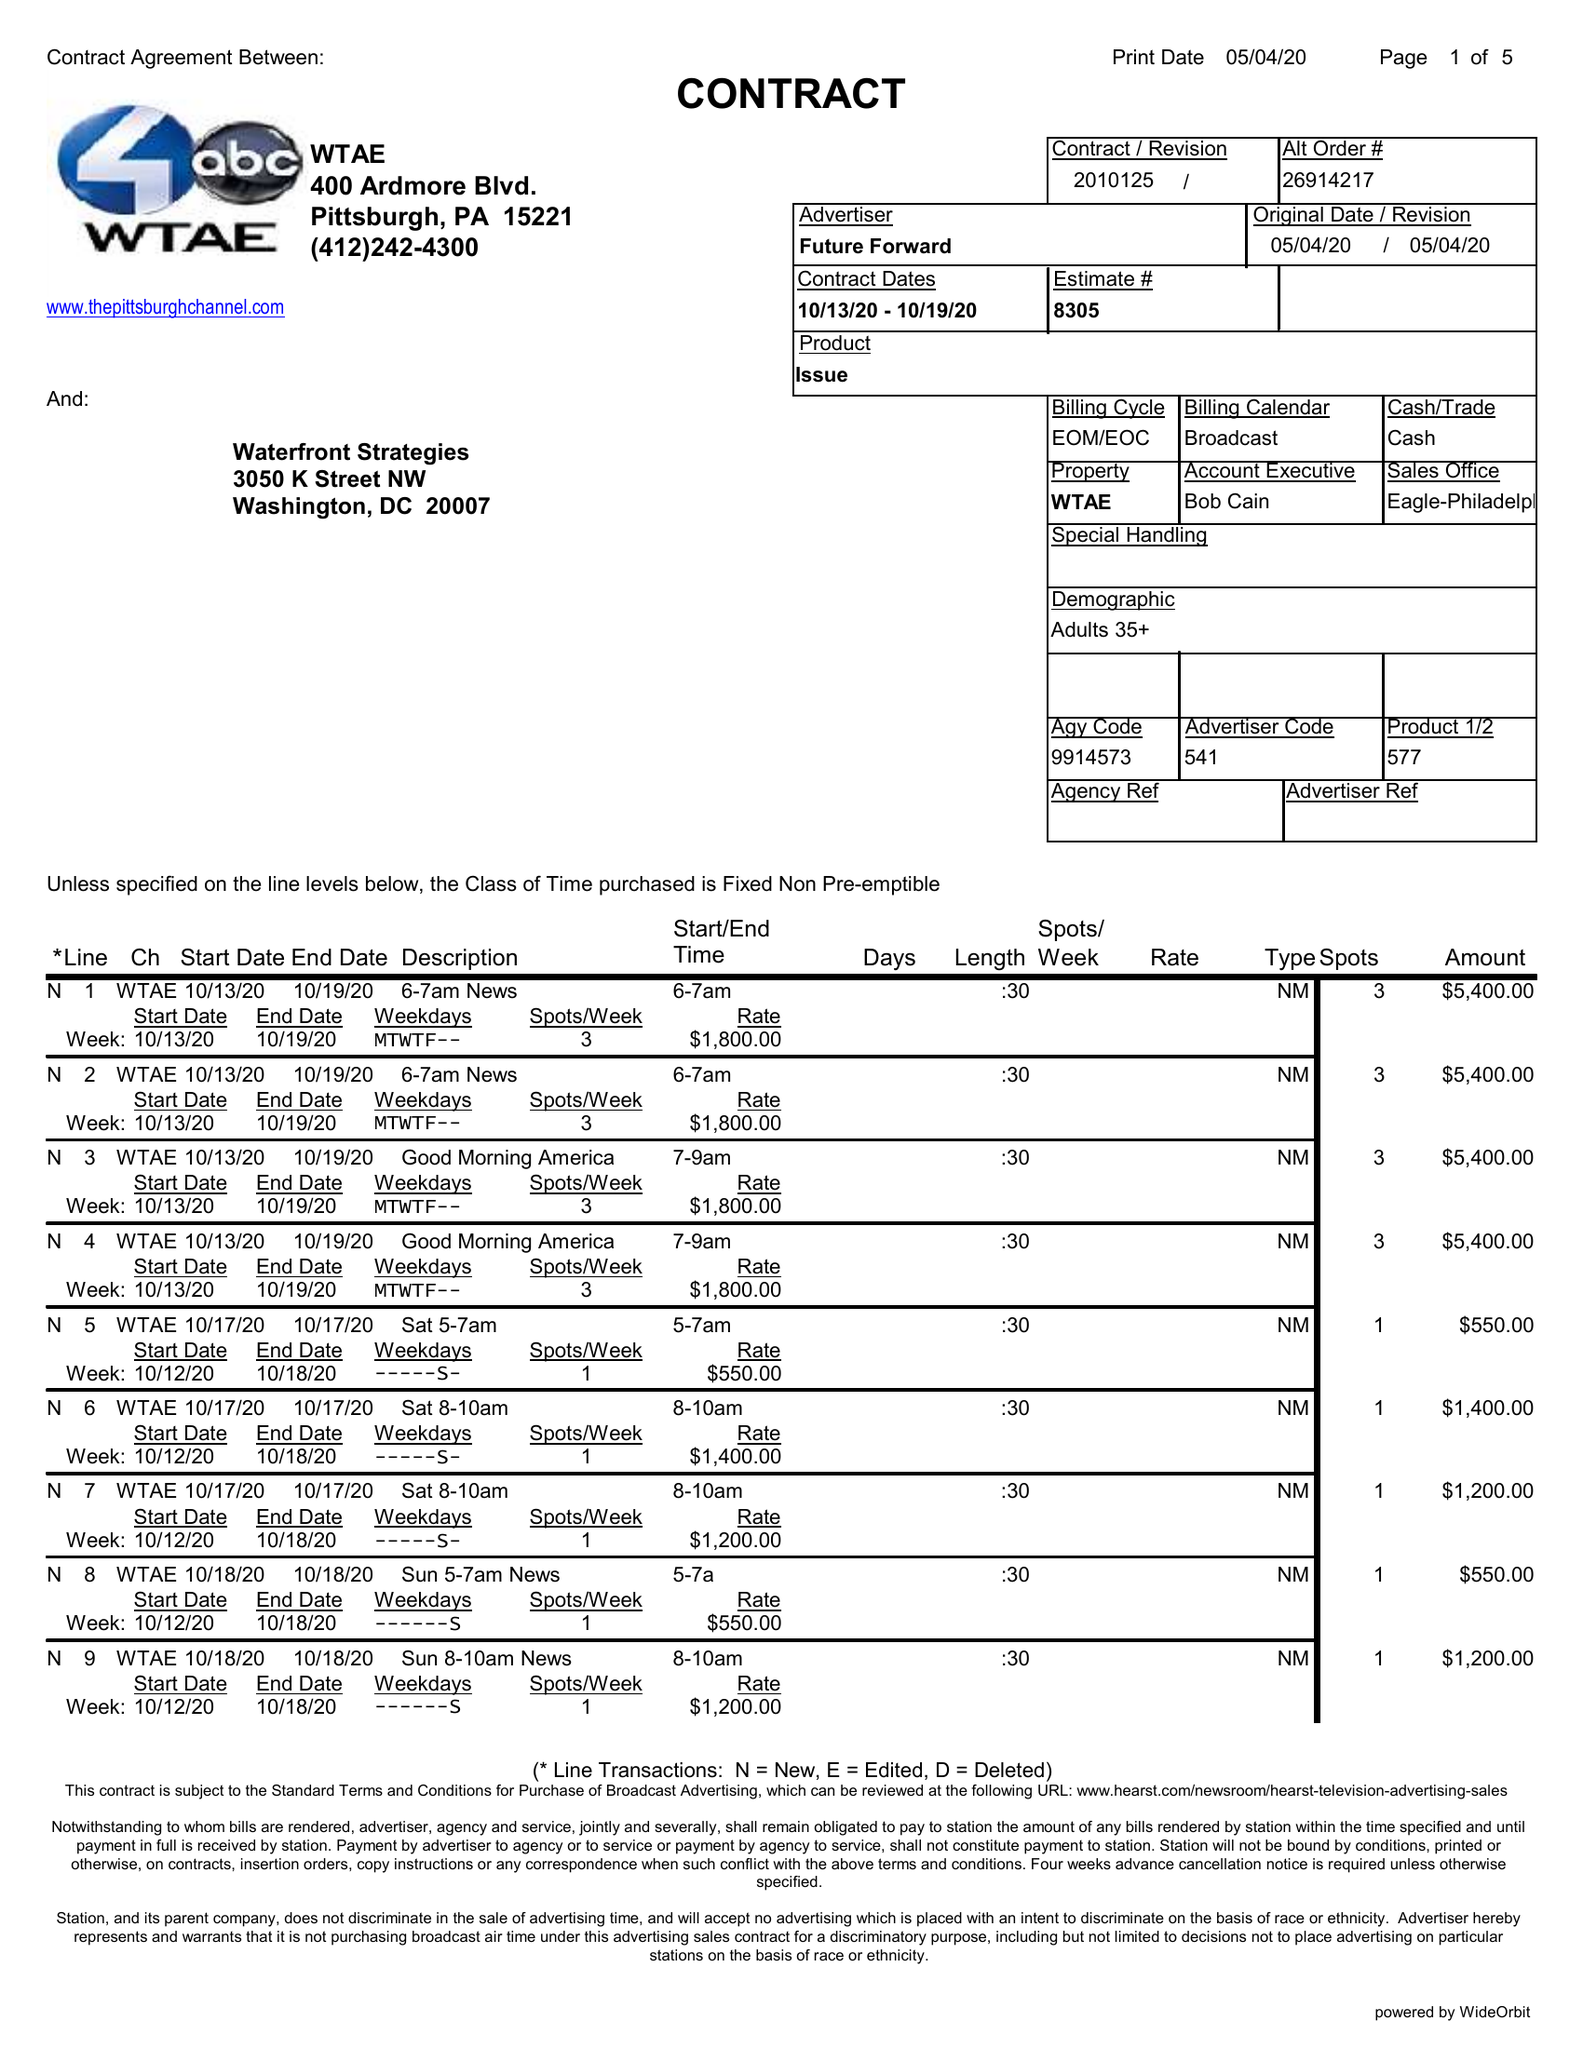What is the value for the advertiser?
Answer the question using a single word or phrase. FUTURE FORWARD 